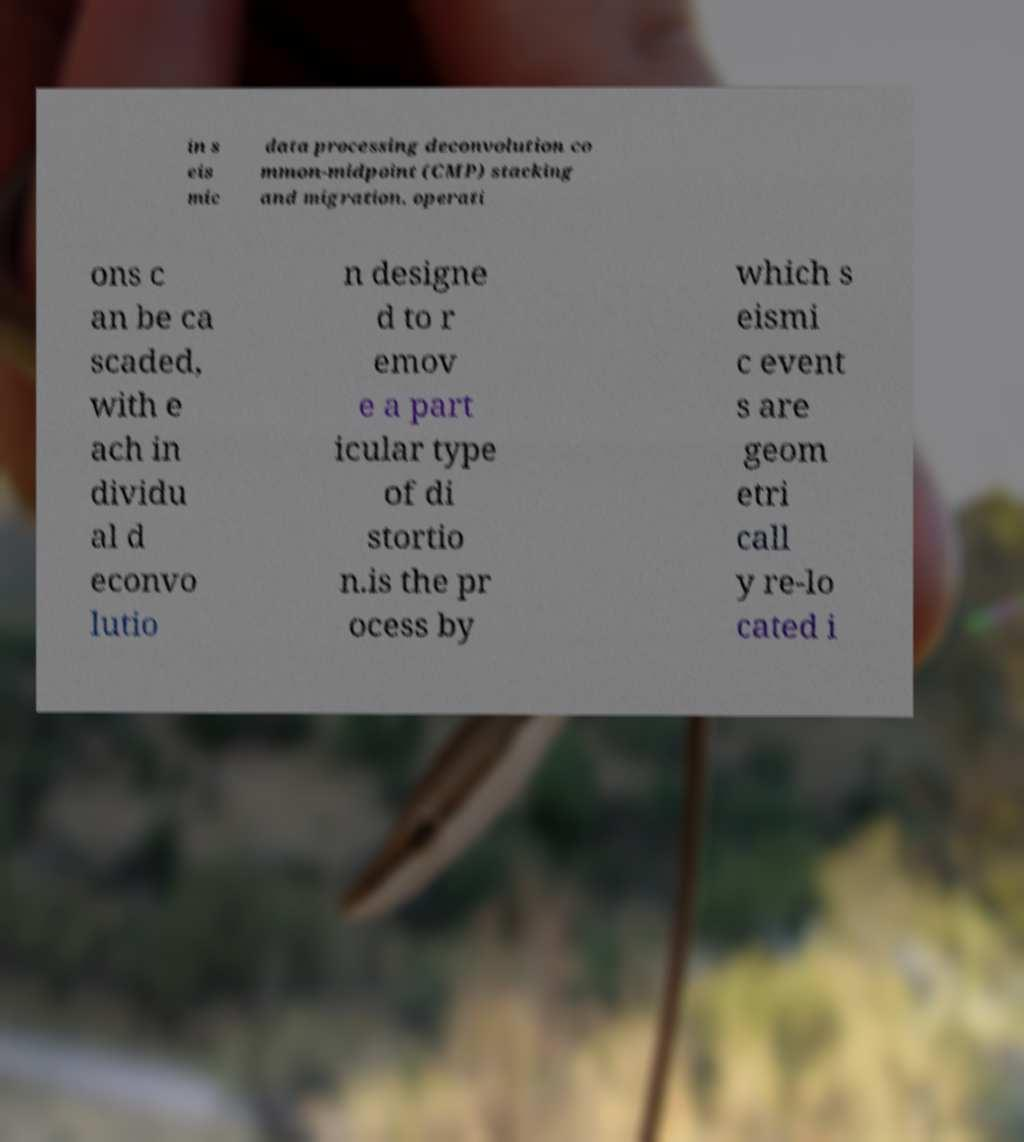Please identify and transcribe the text found in this image. in s eis mic data processing deconvolution co mmon-midpoint (CMP) stacking and migration. operati ons c an be ca scaded, with e ach in dividu al d econvo lutio n designe d to r emov e a part icular type of di stortio n.is the pr ocess by which s eismi c event s are geom etri call y re-lo cated i 